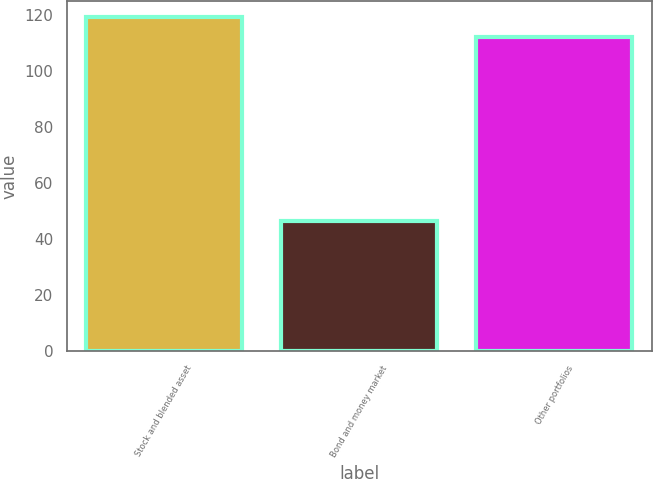Convert chart. <chart><loc_0><loc_0><loc_500><loc_500><bar_chart><fcel>Stock and blended asset<fcel>Bond and money market<fcel>Other portfolios<nl><fcel>119.04<fcel>46.5<fcel>111.9<nl></chart> 